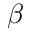Convert formula to latex. <formula><loc_0><loc_0><loc_500><loc_500>\beta</formula> 